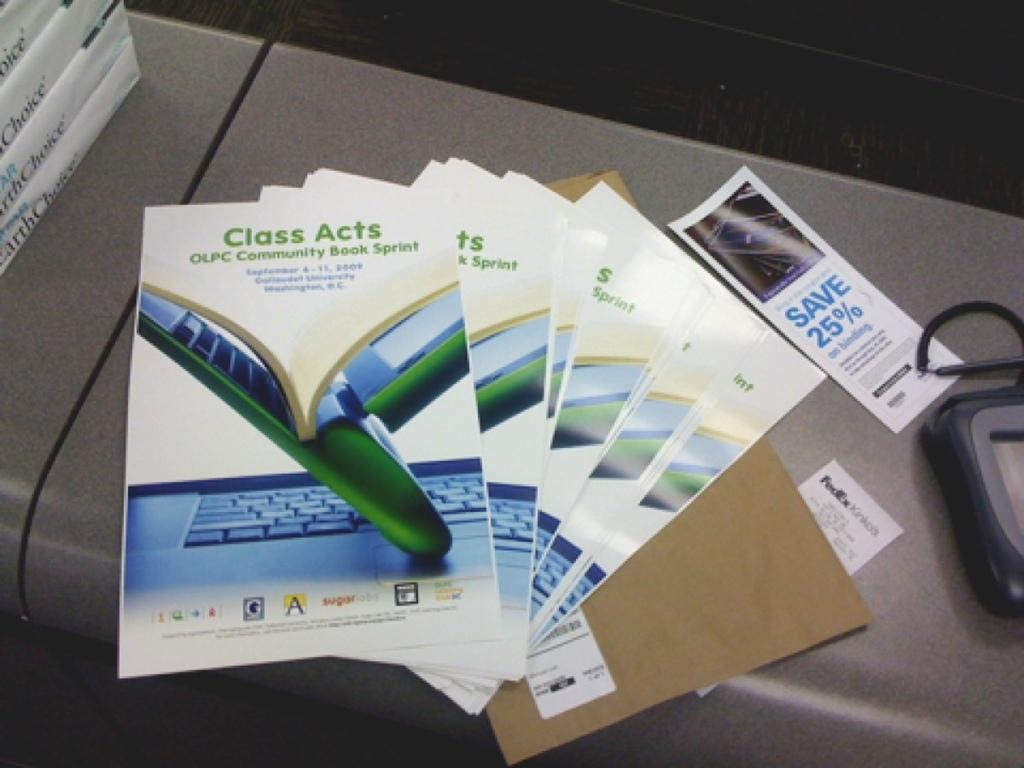Provide a one-sentence caption for the provided image. Class Acts booklets placed on top of one another with a Save 25% coupon on the side. 